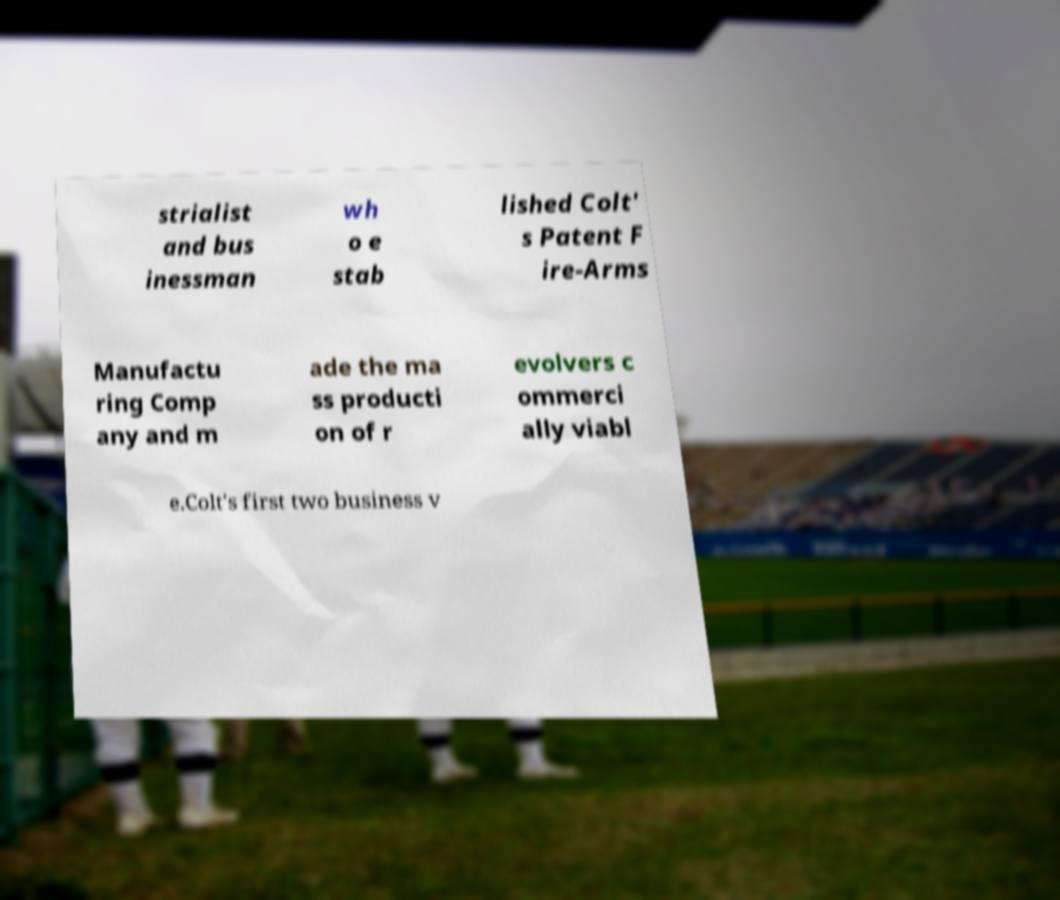Please read and relay the text visible in this image. What does it say? strialist and bus inessman wh o e stab lished Colt' s Patent F ire-Arms Manufactu ring Comp any and m ade the ma ss producti on of r evolvers c ommerci ally viabl e.Colt's first two business v 